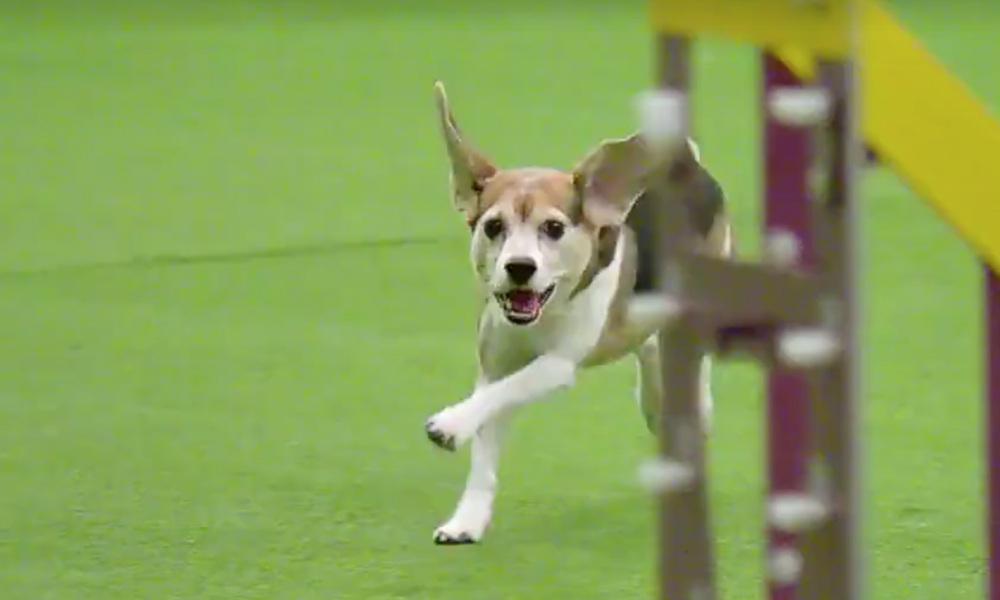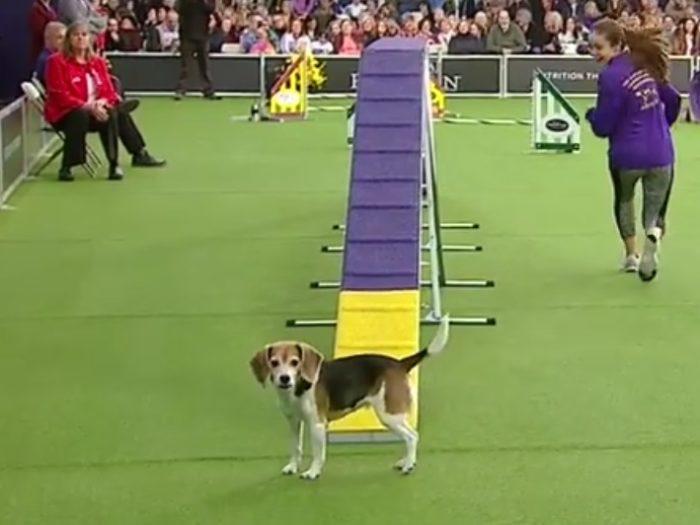The first image is the image on the left, the second image is the image on the right. Given the left and right images, does the statement "One image contains a single Beagle and a girl in a purple shirt on an agility course." hold true? Answer yes or no. Yes. 